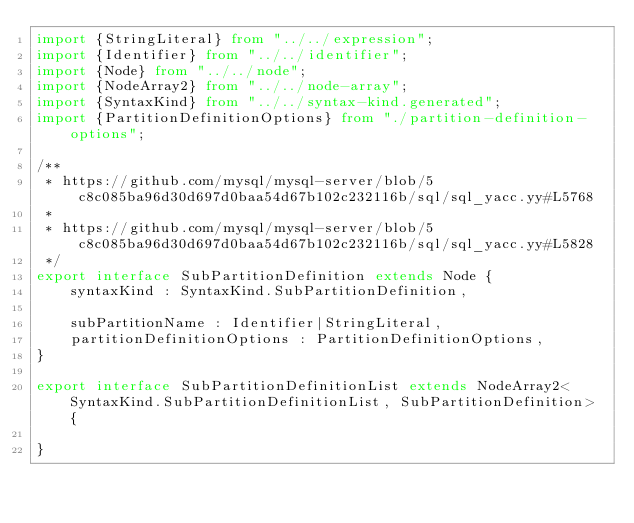<code> <loc_0><loc_0><loc_500><loc_500><_TypeScript_>import {StringLiteral} from "../../expression";
import {Identifier} from "../../identifier";
import {Node} from "../../node";
import {NodeArray2} from "../../node-array";
import {SyntaxKind} from "../../syntax-kind.generated";
import {PartitionDefinitionOptions} from "./partition-definition-options";

/**
 * https://github.com/mysql/mysql-server/blob/5c8c085ba96d30d697d0baa54d67b102c232116b/sql/sql_yacc.yy#L5768
 *
 * https://github.com/mysql/mysql-server/blob/5c8c085ba96d30d697d0baa54d67b102c232116b/sql/sql_yacc.yy#L5828
 */
export interface SubPartitionDefinition extends Node {
    syntaxKind : SyntaxKind.SubPartitionDefinition,

    subPartitionName : Identifier|StringLiteral,
    partitionDefinitionOptions : PartitionDefinitionOptions,
}

export interface SubPartitionDefinitionList extends NodeArray2<SyntaxKind.SubPartitionDefinitionList, SubPartitionDefinition> {

}
</code> 